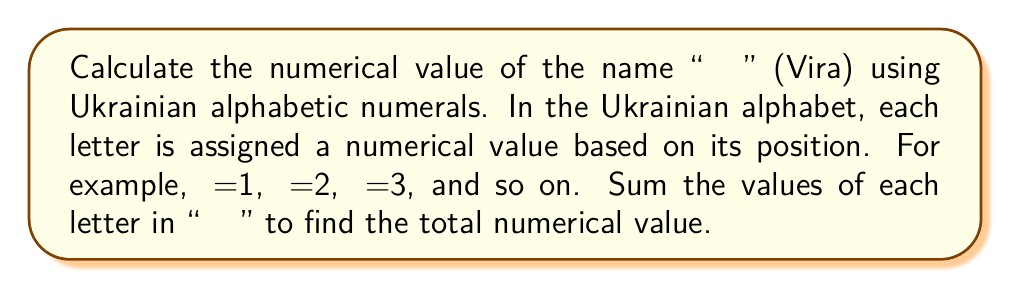Can you solve this math problem? To solve this problem, we need to follow these steps:

1. Identify the position of each letter in "Віра" within the Ukrainian alphabet:
   В (ve) is the 3rd letter
   І (i) is the 11th letter
   Р (er) is the 23rd letter
   А (a) is the 1st letter

2. Assign numerical values to each letter based on its position:
   В = 3
   І = 11
   Р = 23
   А = 1

3. Sum the numerical values:

   $$ \text{Total} = В + І + Р + А $$
   $$ \text{Total} = 3 + 11 + 23 + 1 $$
   $$ \text{Total} = 38 $$

Therefore, the numerical value of "Віра" using Ukrainian alphabetic numerals is 38.
Answer: $$ 38 $$ 